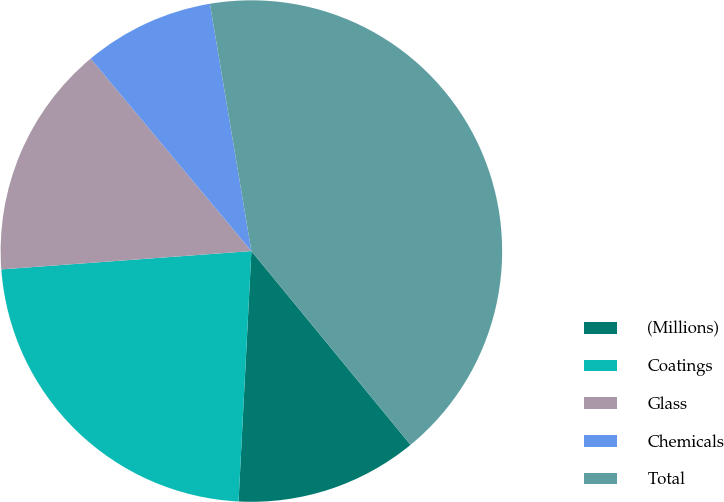<chart> <loc_0><loc_0><loc_500><loc_500><pie_chart><fcel>(Millions)<fcel>Coatings<fcel>Glass<fcel>Chemicals<fcel>Total<nl><fcel>11.76%<fcel>23.02%<fcel>15.09%<fcel>8.43%<fcel>41.7%<nl></chart> 